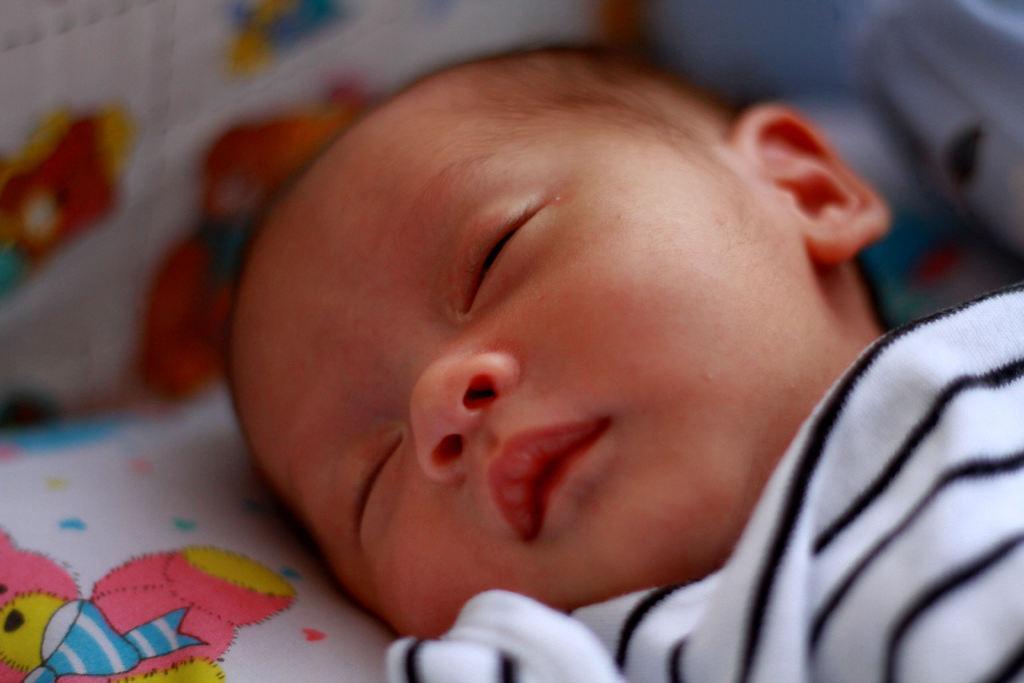In one or two sentences, can you explain what this image depicts? In this image there is a kid sleeping. 